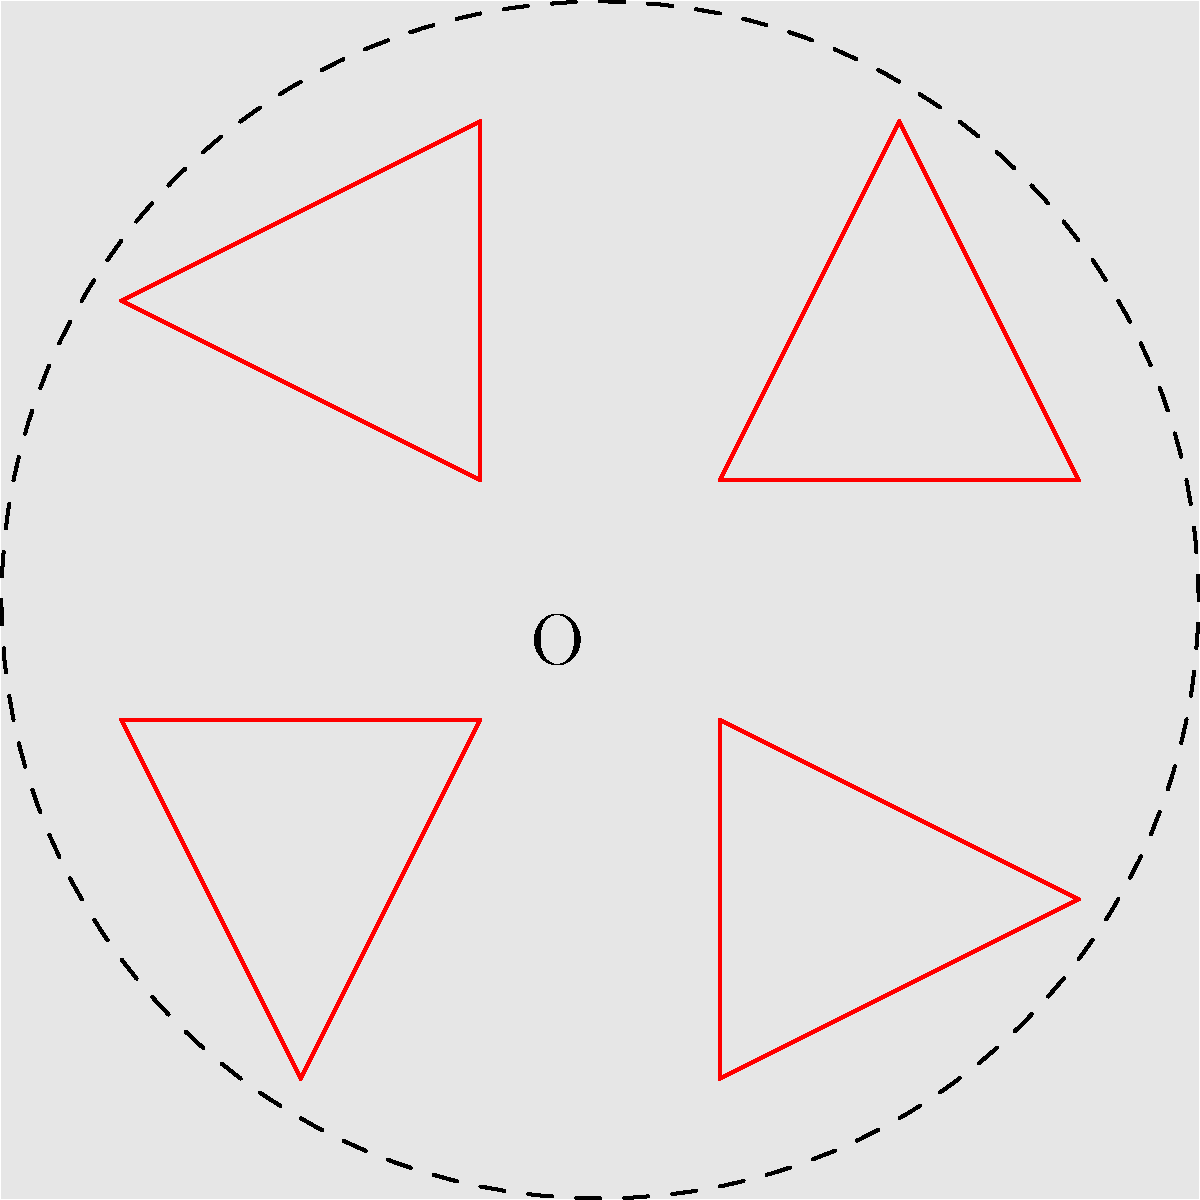A traditional indigenous pattern is represented by the red triangle in the diagram. If this pattern is rotated around the origin O by multiples of 90°, how many times does the pattern need to be rotated to create a symmetrical design that looks identical to the original orientation? To solve this problem, we need to understand the concept of rotational symmetry and analyze the given pattern:

1. The original pattern is a red triangle within a square.
2. The diagram shows the pattern rotated four times around the origin O, each rotation by 90°.
3. To determine how many rotations are needed for the design to look identical to the original, we need to find the smallest rotation that brings the pattern back to its starting position.

Let's consider the rotations:
- After 90°: The pattern is different from the original.
- After 180°: The pattern is still different from the original.
- After 270°: The pattern is still different from the original.
- After 360° (or 4 rotations of 90°): The pattern returns to its original position.

Therefore, the pattern needs to be rotated 4 times by 90° (or once by 360°) to create a symmetrical design that looks identical to the original orientation.

This is also evident from the diagram, where we can see that after four 90° rotations, the pattern completes a full circle and returns to its starting position.
Answer: 4 rotations 